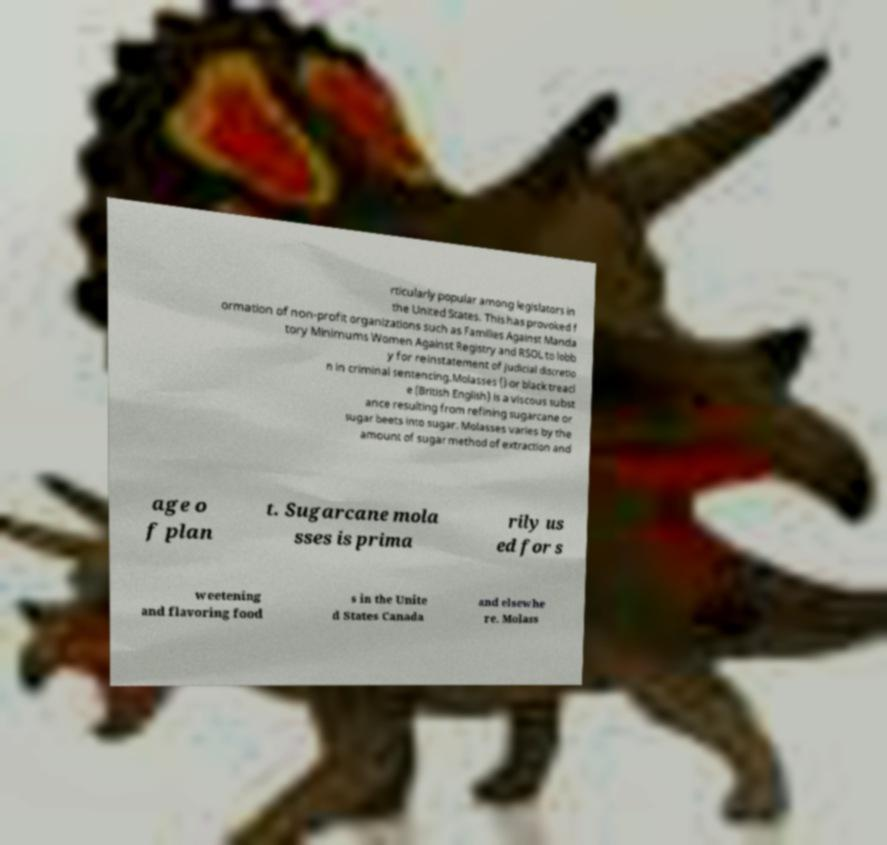I need the written content from this picture converted into text. Can you do that? rticularly popular among legislators in the United States. This has provoked f ormation of non-profit organizations such as Families Against Manda tory Minimums Women Against Registry and RSOL to lobb y for reinstatement of judicial discretio n in criminal sentencing.Molasses () or black treacl e (British English) is a viscous subst ance resulting from refining sugarcane or sugar beets into sugar. Molasses varies by the amount of sugar method of extraction and age o f plan t. Sugarcane mola sses is prima rily us ed for s weetening and flavoring food s in the Unite d States Canada and elsewhe re. Molass 